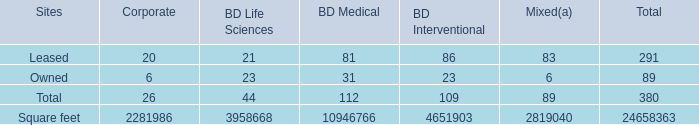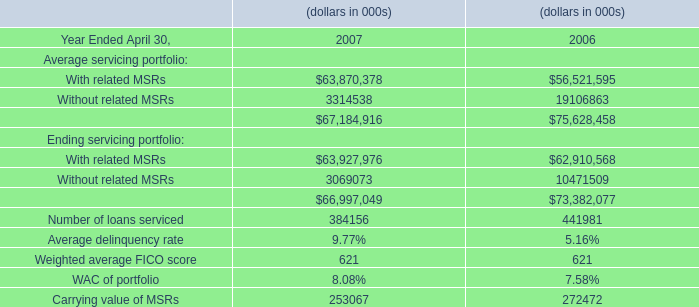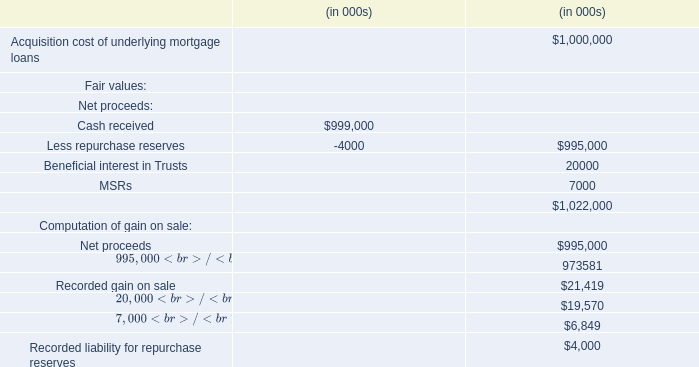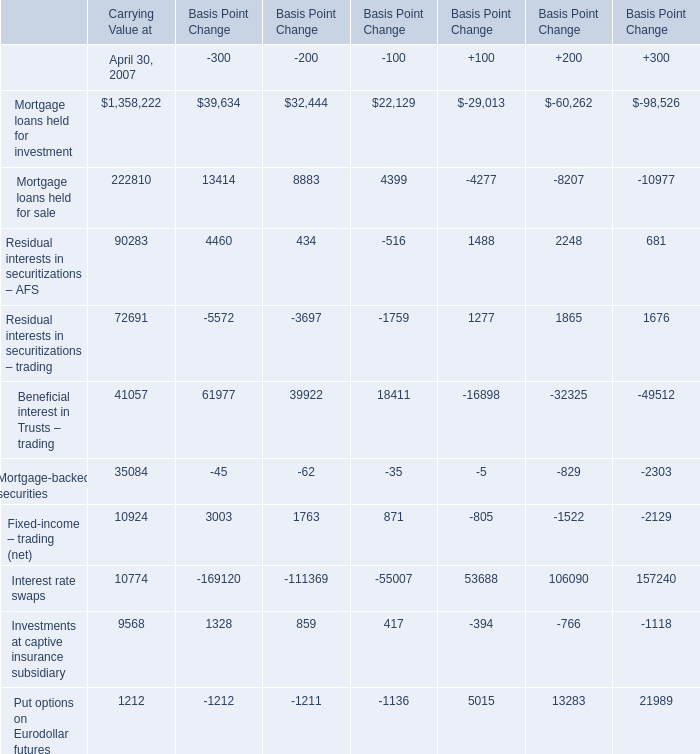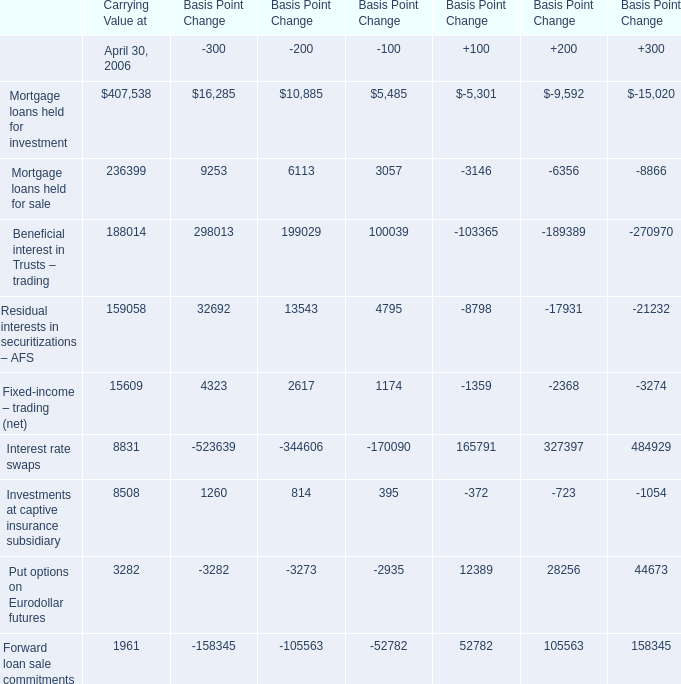what is the average square footage of leased corporate sites? 
Computations: (2281986 / 20)
Answer: 114099.3. 